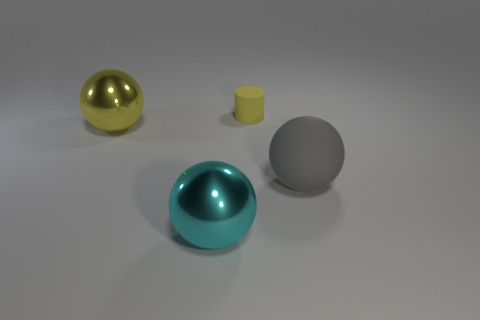Add 2 large yellow rubber cubes. How many objects exist? 6 Subtract all cylinders. How many objects are left? 3 Subtract all gray rubber spheres. Subtract all small red blocks. How many objects are left? 3 Add 2 large shiny things. How many large shiny things are left? 4 Add 3 tiny yellow matte cylinders. How many tiny yellow matte cylinders exist? 4 Subtract 0 blue balls. How many objects are left? 4 